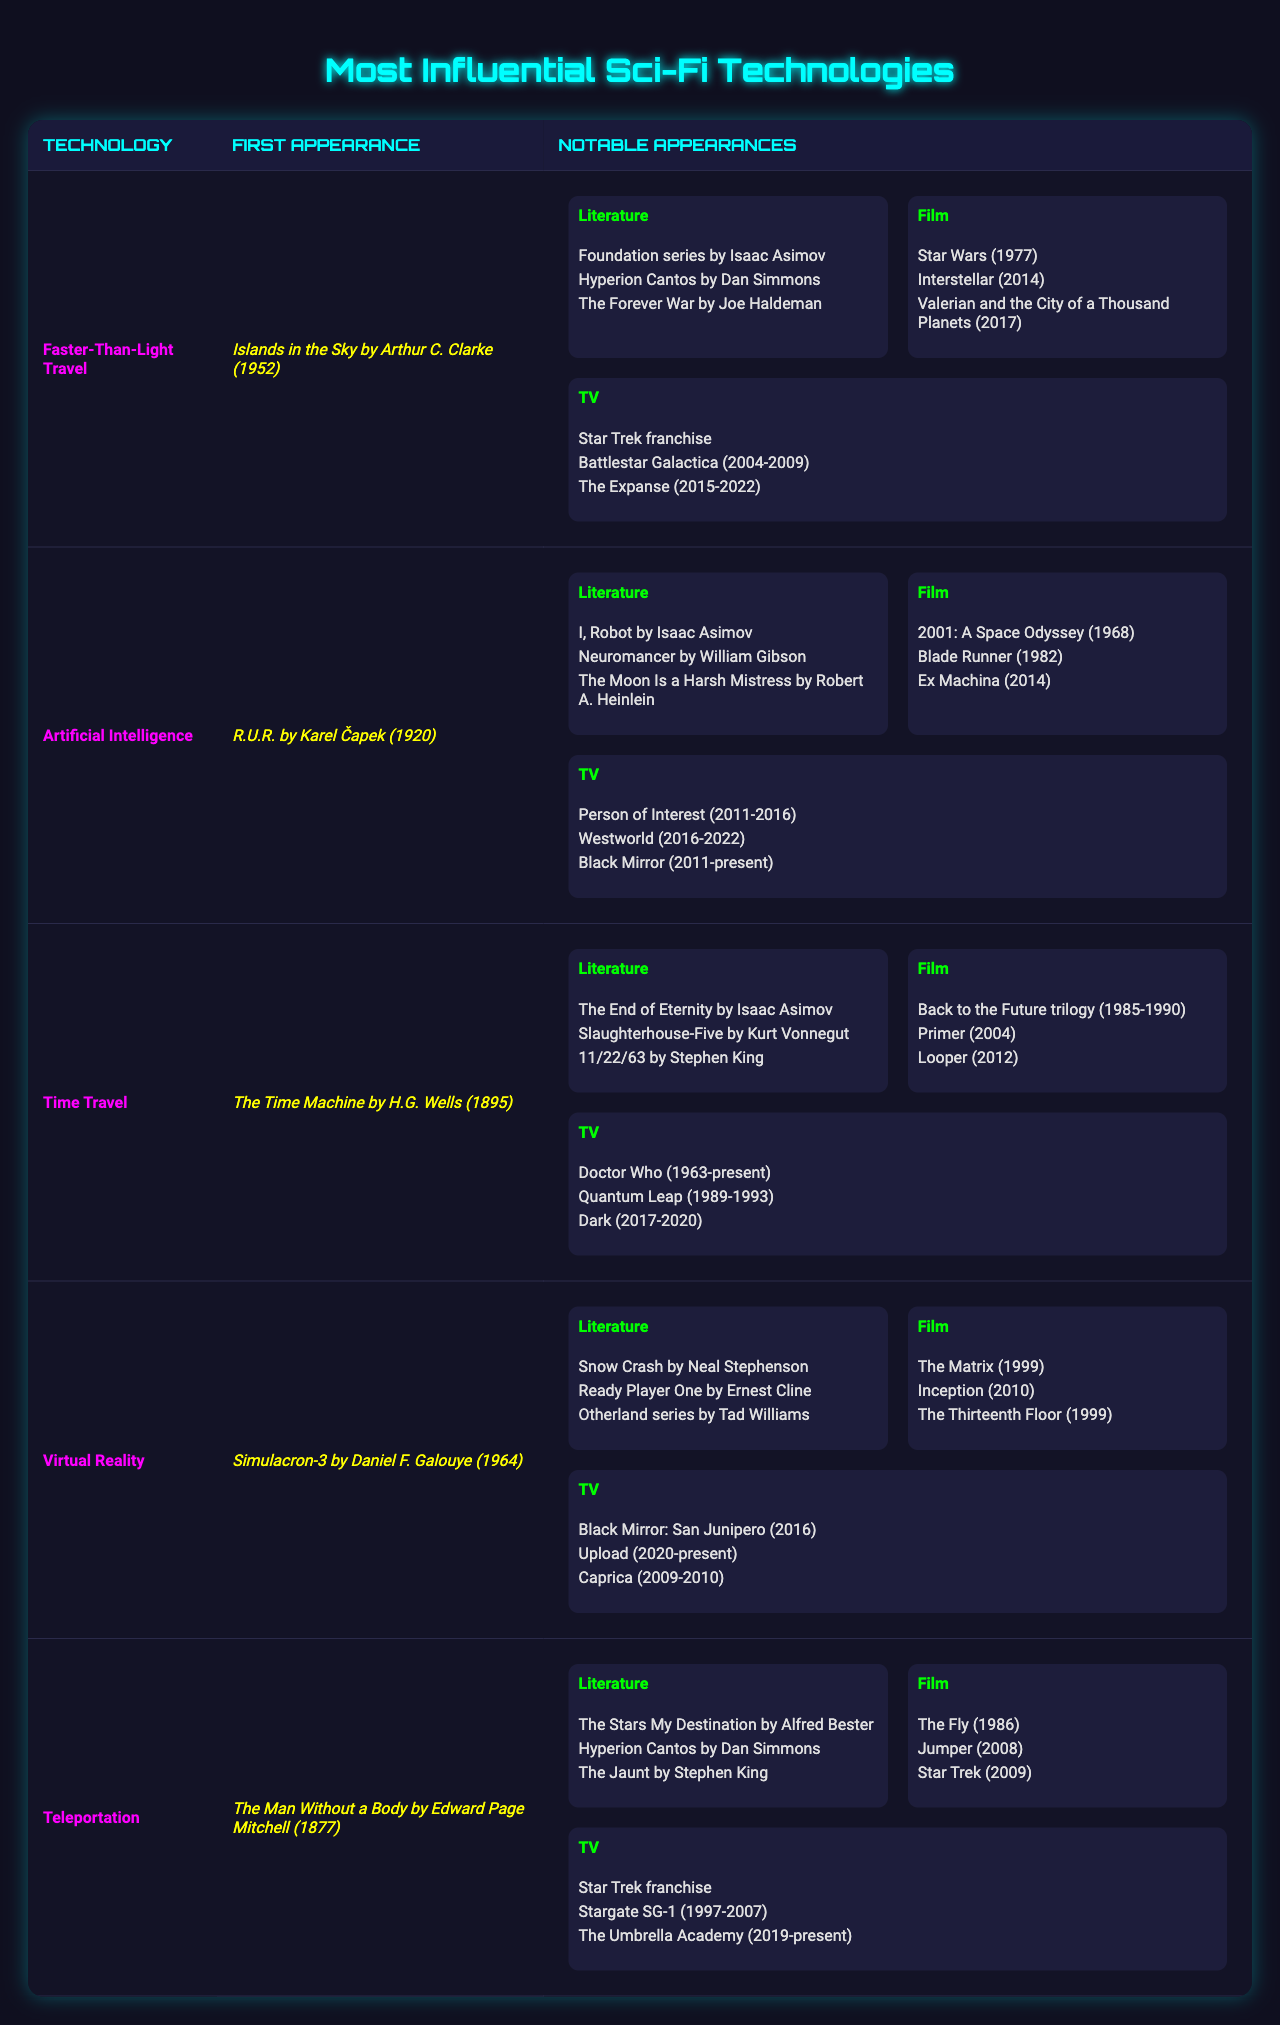What is the first appearance of Faster-Than-Light Travel? The first appearance of Faster-Than-Light Travel is noted in the table as "Islands in the Sky by Arthur C. Clarke (1952)".
Answer: Islands in the Sky by Arthur C. Clarke (1952) Which technology first appeared in literature in 1920? By looking at the "First Appearance" column, we can see that Artificial Intelligence is the technology that first appeared in literature in 1920, according to the table.
Answer: Artificial Intelligence How many different films feature Time Travel technology? The table lists three notable films for Time Travel: "Back to the Future trilogy", "Primer", and "Looper". Counting these gives us three films in total.
Answer: 3 Is there any technology that has notable appearances in both literature and film? By examining the table, we can find technologies like Faster-Than-Light Travel and Artificial Intelligence that have notable appearances listed under both literature and film sections, which indicates that the answer is yes.
Answer: Yes Which technology has more notable appearances in TV than in literature? By counting the notable appearances for each technology, we see that Virtual Reality has three notable TV shows and three notable literature works listed, while Teleportation also has three for each. However, Time Travel only has three for literature but four for TV since its first appearance has a significant impact. The answer is Time Travel.
Answer: Time Travel List the notable films for Artificial Intelligence. The notable films listed for Artificial Intelligence in the table are "2001: A Space Odyssey", "Blade Runner", and "Ex Machina".
Answer: 2001: A Space Odyssey, Blade Runner, Ex Machina Which technology was first introduced in a work from the 19th century? Looking at the table, Teleportation is the only technology that first appeared in a work from the 19th century, specifically in "The Man Without a Body" by Edward Page Mitchell (1877).
Answer: Teleportation What is the total count of notable appearances in literature for Virtual Reality? The table shows that Virtual Reality has three notable literature appearances: "Snow Crash", "Ready Player One", and "Otherland series". Thus, the total count is three.
Answer: 3 Does any technology have the same number of memorable appearances in film and TV? Analyzing the table reveals that Teleportation has three notable appearances in both film and TV. Therefore, it can be concluded that the answer to this question is yes.
Answer: Yes Which technology has the most notable appearances overall (in literature, film, and TV combined)? By counting all notable appearances for each technology: Faster-Than-Light Travel has 10, Artificial Intelligence has 9, Time Travel has 9, Virtual Reality has 9, and Teleportation has 9. Faster-Than-Light Travel has the most with 10 total appearances.
Answer: Faster-Than-Light Travel 